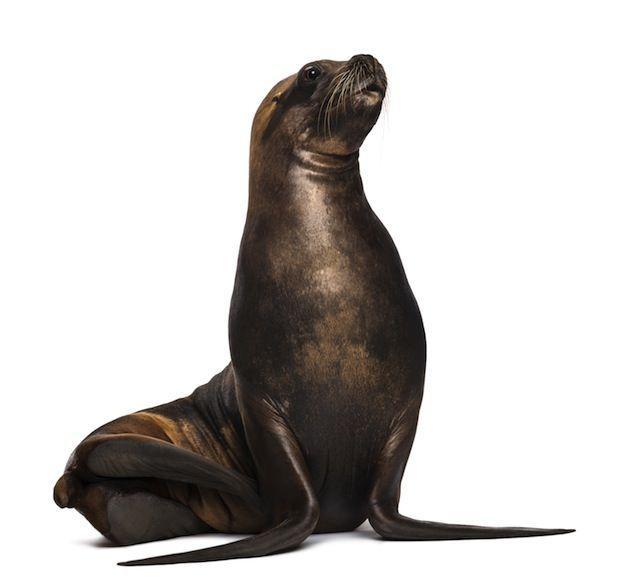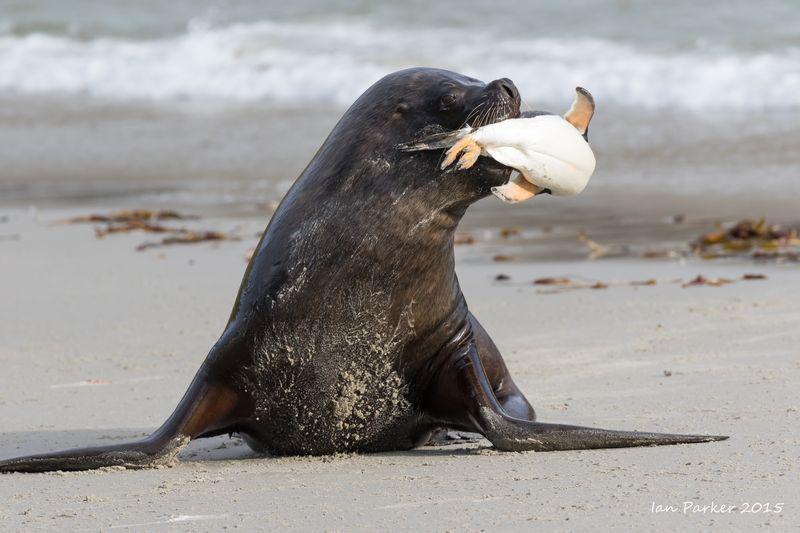The first image is the image on the left, the second image is the image on the right. For the images shown, is this caption "There is one seal with a plain white background." true? Answer yes or no. Yes. The first image is the image on the left, the second image is the image on the right. Evaluate the accuracy of this statement regarding the images: "The seals in the right and left images have their bodies turned in different [left vs right] directions, and no seals shown are babies.". Is it true? Answer yes or no. No. 